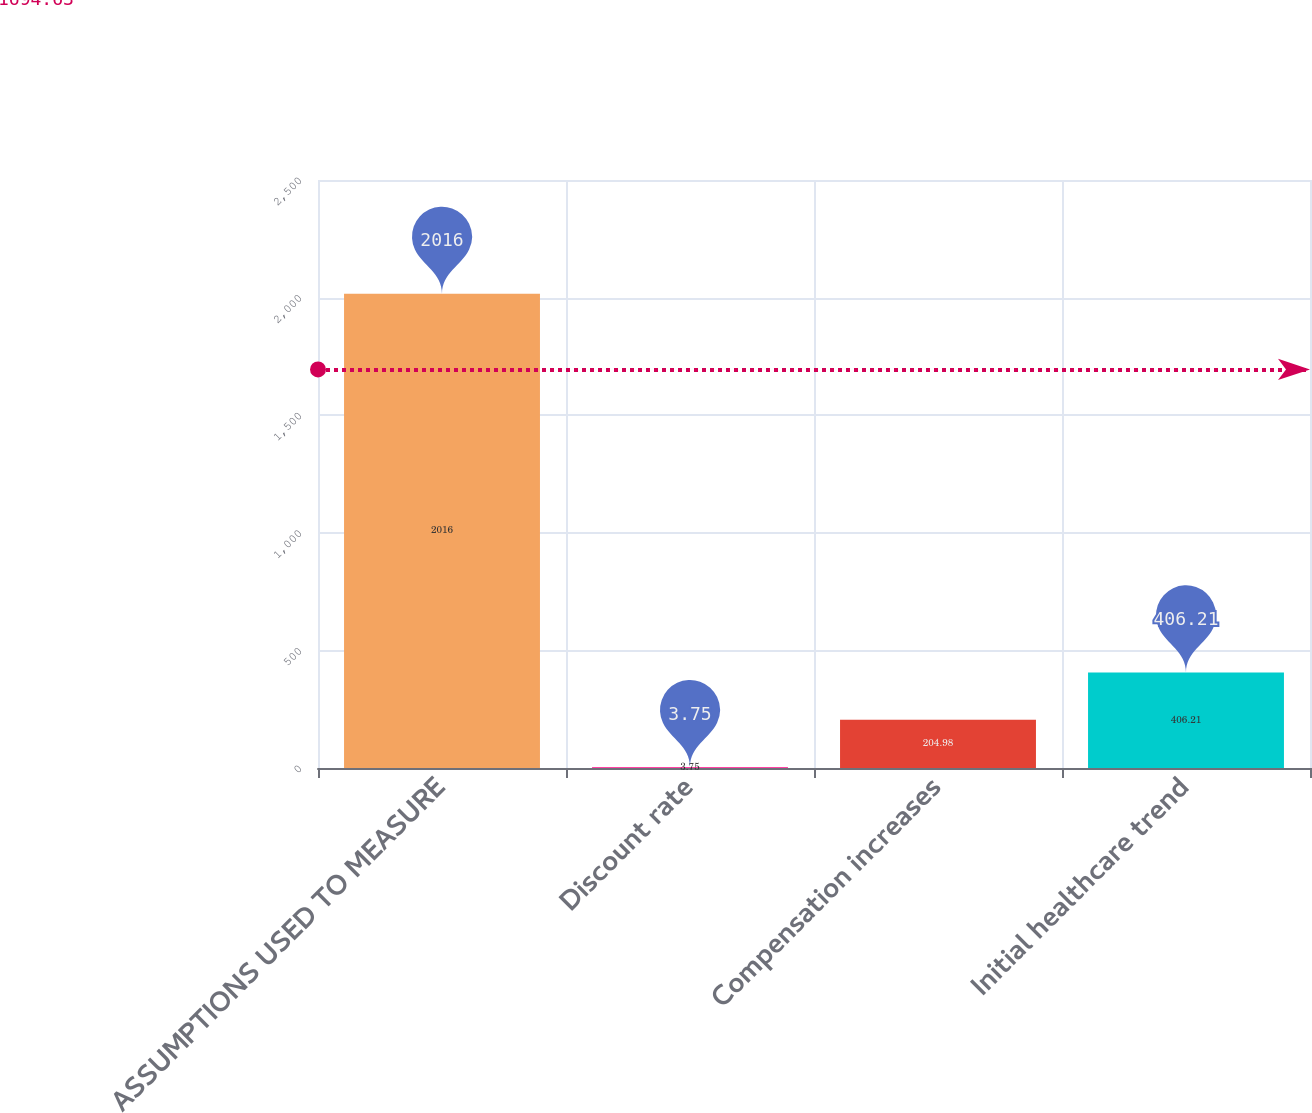Convert chart. <chart><loc_0><loc_0><loc_500><loc_500><bar_chart><fcel>ASSUMPTIONS USED TO MEASURE<fcel>Discount rate<fcel>Compensation increases<fcel>Initial healthcare trend<nl><fcel>2016<fcel>3.75<fcel>204.98<fcel>406.21<nl></chart> 